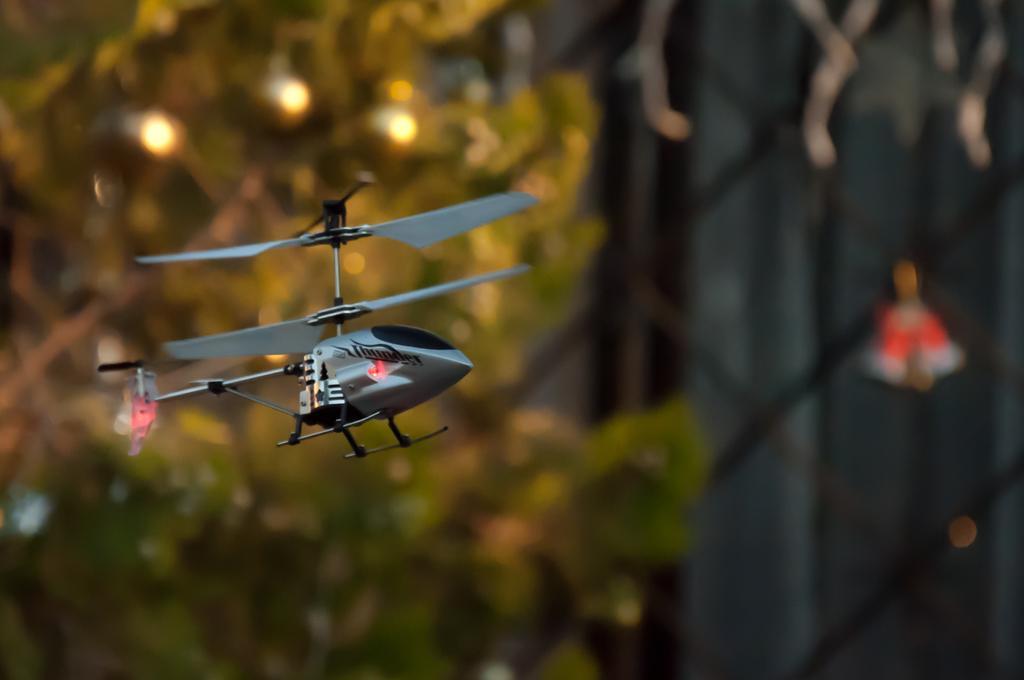How would you summarize this image in a sentence or two? In this image in the center there is one toy helicopter, and in the background there are trees and the background is blurred. 